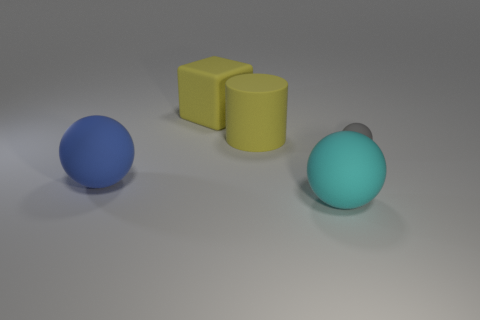What number of other things are the same size as the cyan matte ball?
Provide a succinct answer. 3. How many tiny gray things are in front of the big blue sphere?
Offer a very short reply. 0. What size is the cyan thing?
Provide a succinct answer. Large. Do the big thing on the left side of the yellow matte cube and the thing on the right side of the cyan ball have the same material?
Give a very brief answer. Yes. Are there any other big matte blocks of the same color as the large matte cube?
Ensure brevity in your answer.  No. What is the color of the rubber block that is the same size as the cylinder?
Provide a succinct answer. Yellow. Do the large ball to the left of the yellow cylinder and the rubber cube have the same color?
Make the answer very short. No. Are there any gray balls that have the same material as the blue ball?
Make the answer very short. Yes. There is a object that is the same color as the matte cylinder; what is its shape?
Ensure brevity in your answer.  Cube. Is the number of cyan rubber things that are on the left side of the big yellow block less than the number of red metallic cylinders?
Offer a very short reply. No. 